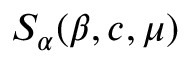Convert formula to latex. <formula><loc_0><loc_0><loc_500><loc_500>S _ { \alpha } ( \beta , c , \mu )</formula> 